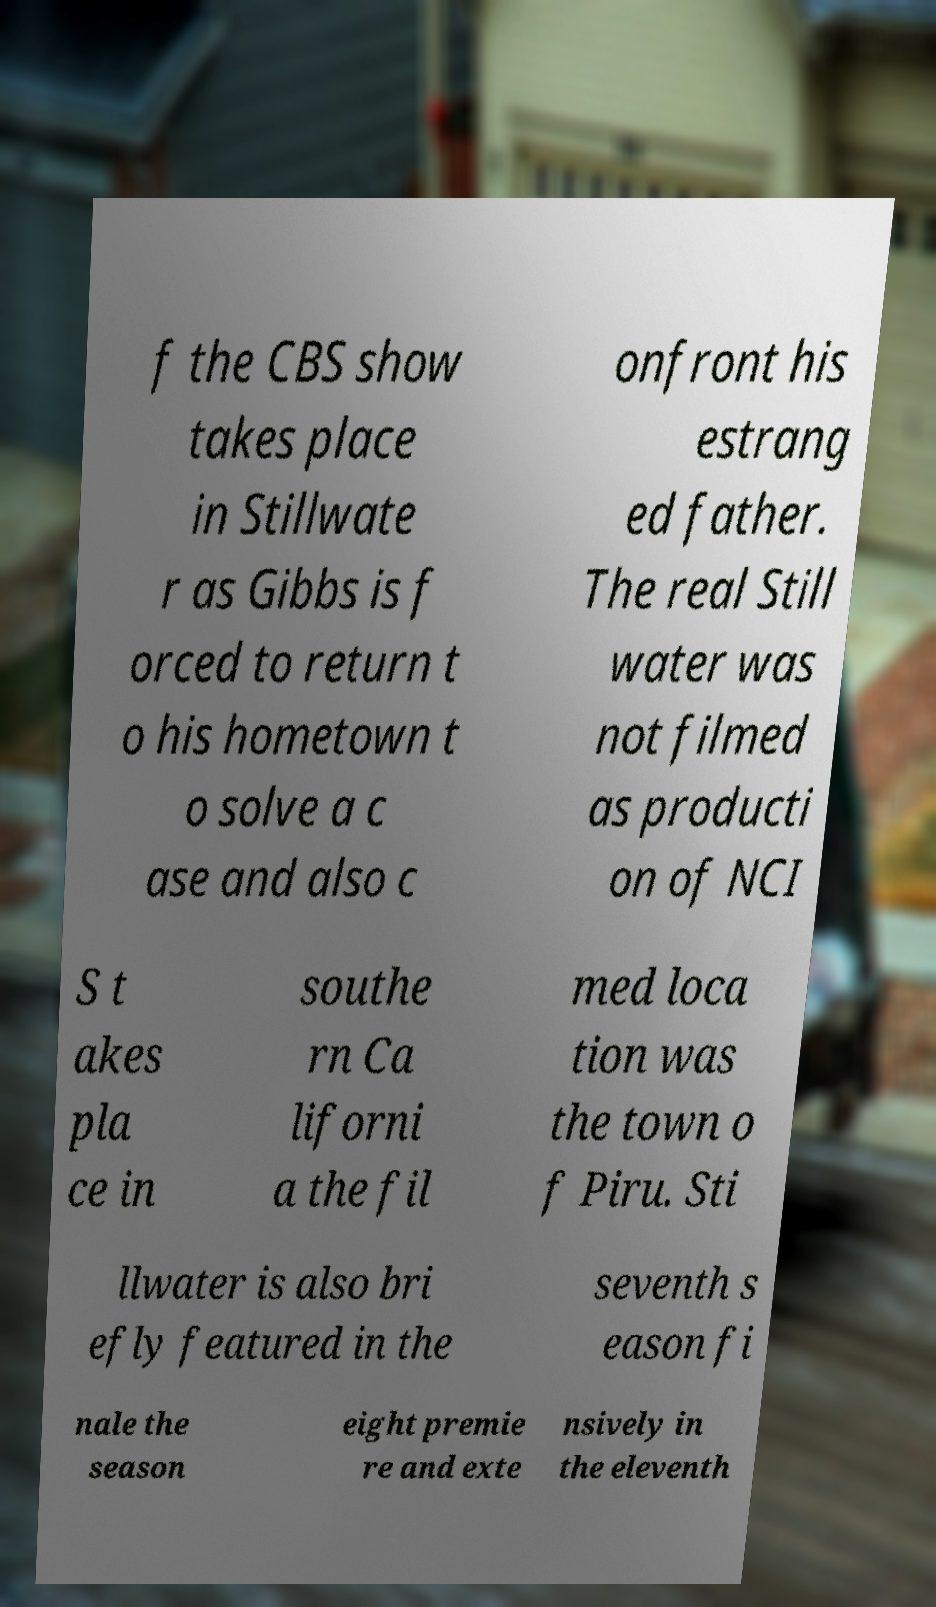There's text embedded in this image that I need extracted. Can you transcribe it verbatim? f the CBS show takes place in Stillwate r as Gibbs is f orced to return t o his hometown t o solve a c ase and also c onfront his estrang ed father. The real Still water was not filmed as producti on of NCI S t akes pla ce in southe rn Ca liforni a the fil med loca tion was the town o f Piru. Sti llwater is also bri efly featured in the seventh s eason fi nale the season eight premie re and exte nsively in the eleventh 